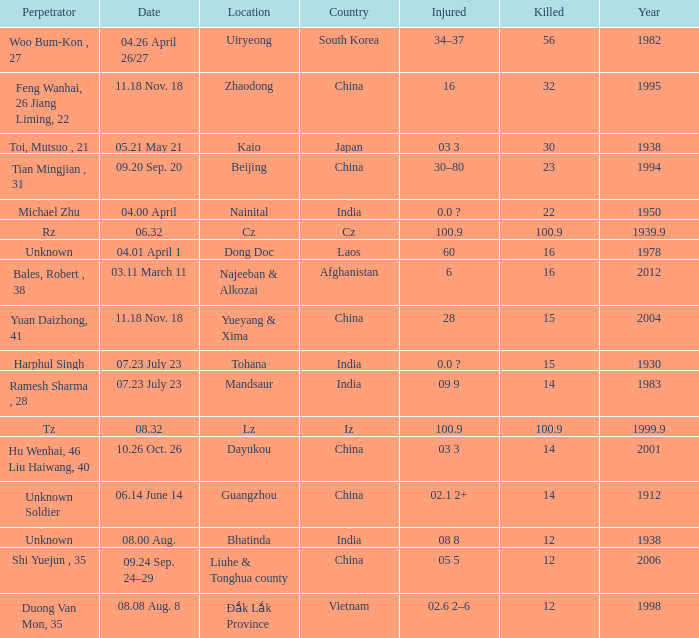What is the average Year, when Date is "04.01 April 1"? 1978.0. 